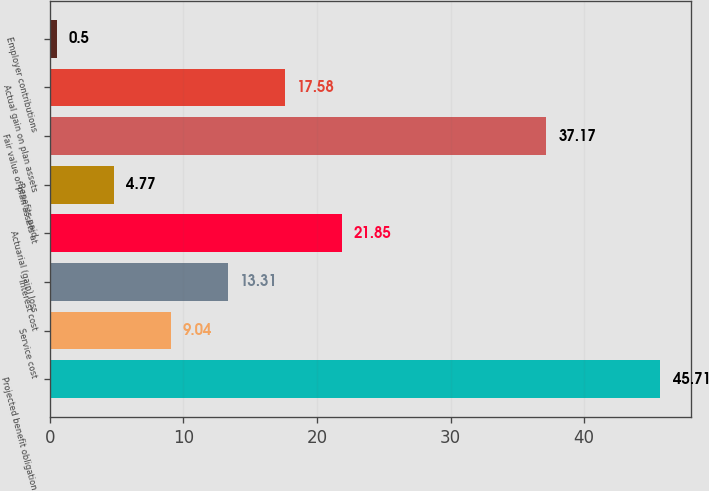<chart> <loc_0><loc_0><loc_500><loc_500><bar_chart><fcel>Projected benefit obligation<fcel>Service cost<fcel>Interest cost<fcel>Actuarial (gain) loss<fcel>Benefits paid<fcel>Fair value of plan assets at<fcel>Actual gain on plan assets<fcel>Employer contributions<nl><fcel>45.71<fcel>9.04<fcel>13.31<fcel>21.85<fcel>4.77<fcel>37.17<fcel>17.58<fcel>0.5<nl></chart> 